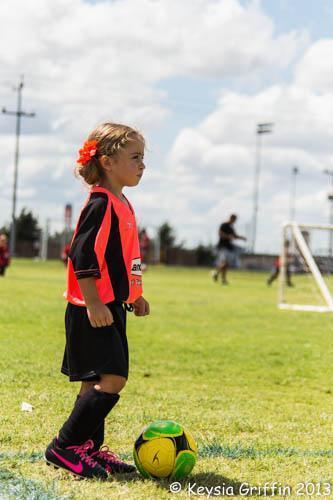How many people with the ball?
Give a very brief answer. 1. 